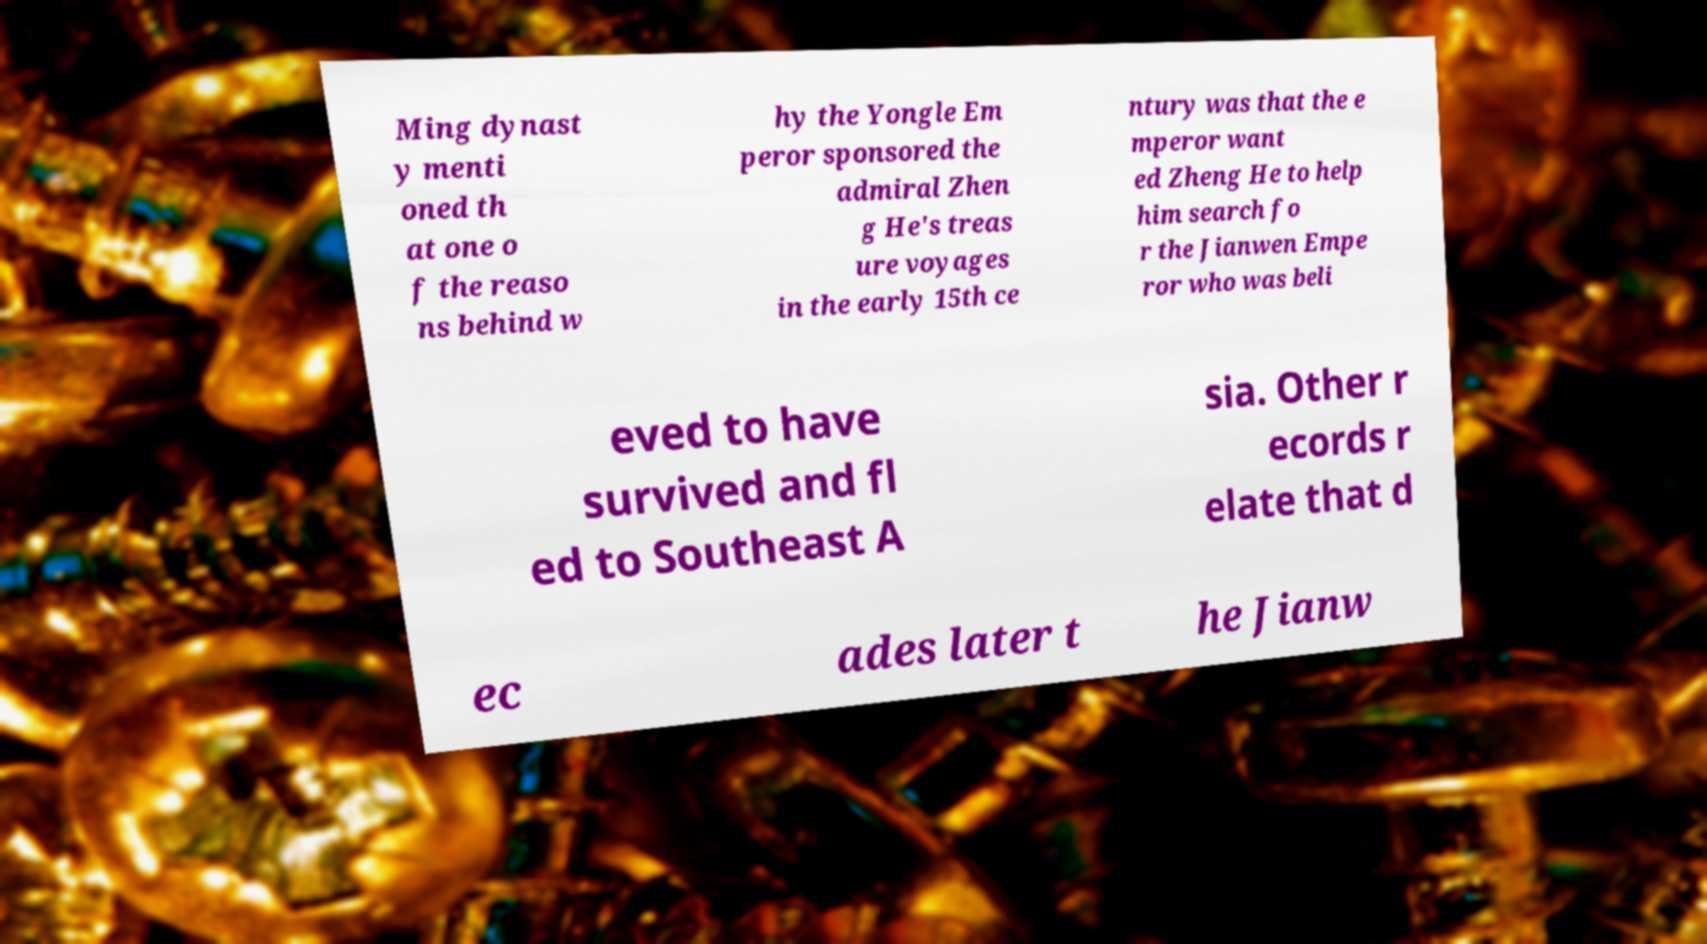Can you read and provide the text displayed in the image?This photo seems to have some interesting text. Can you extract and type it out for me? Ming dynast y menti oned th at one o f the reaso ns behind w hy the Yongle Em peror sponsored the admiral Zhen g He's treas ure voyages in the early 15th ce ntury was that the e mperor want ed Zheng He to help him search fo r the Jianwen Empe ror who was beli eved to have survived and fl ed to Southeast A sia. Other r ecords r elate that d ec ades later t he Jianw 